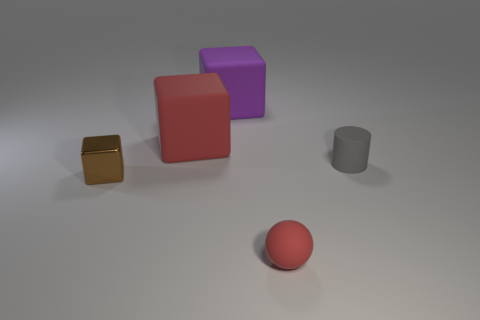What can you infer about the size of the room? Given the scale and spacing of the objects, and the lack of visible boundaries, the actual size of the room is indeterminate; it could be large or small depending on the context beyond the visible frame. 